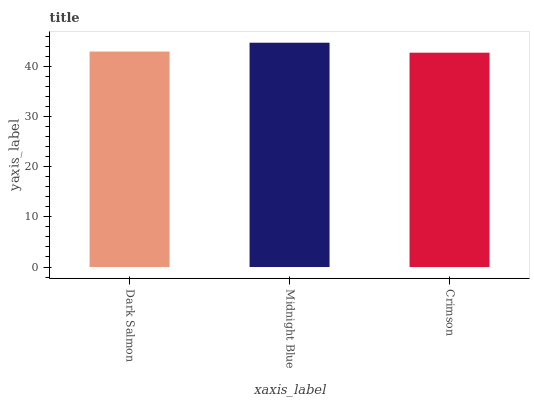Is Crimson the minimum?
Answer yes or no. Yes. Is Midnight Blue the maximum?
Answer yes or no. Yes. Is Midnight Blue the minimum?
Answer yes or no. No. Is Crimson the maximum?
Answer yes or no. No. Is Midnight Blue greater than Crimson?
Answer yes or no. Yes. Is Crimson less than Midnight Blue?
Answer yes or no. Yes. Is Crimson greater than Midnight Blue?
Answer yes or no. No. Is Midnight Blue less than Crimson?
Answer yes or no. No. Is Dark Salmon the high median?
Answer yes or no. Yes. Is Dark Salmon the low median?
Answer yes or no. Yes. Is Crimson the high median?
Answer yes or no. No. Is Midnight Blue the low median?
Answer yes or no. No. 